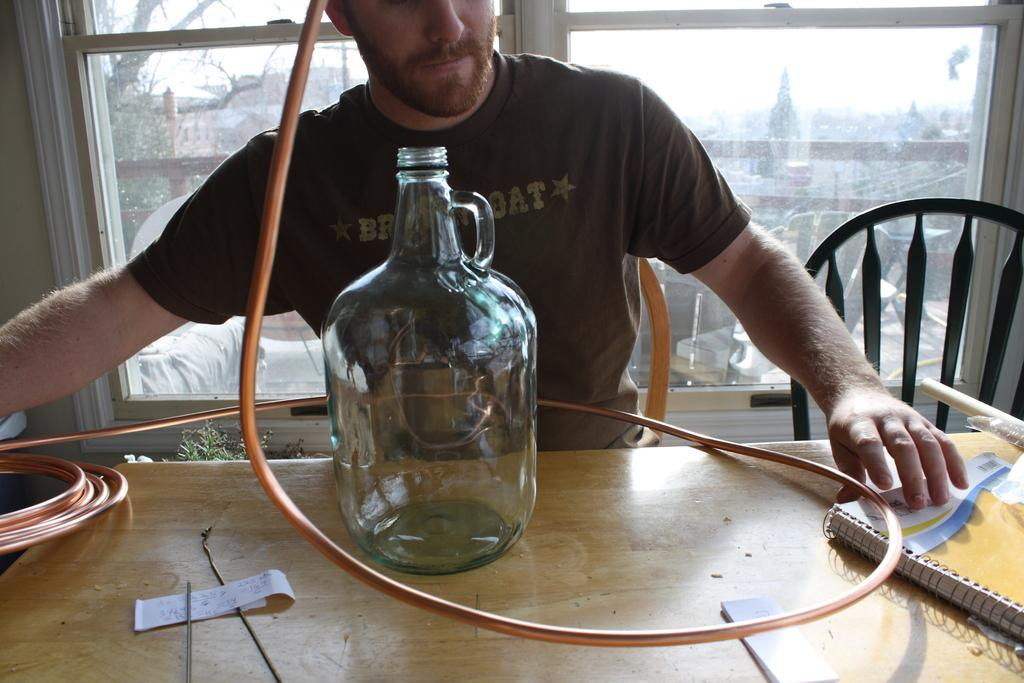What is the person in the image doing? There is a person sitting on a chair in the image. What objects are on the table in the image? There is a pipe, a jar, and a book on the table in the image. What can be seen through the window in the room? Trees and a building are visible through the window in the room. What nation is the person in the image representing? There is no information about the person's nationality or any representation of a nation in the image. 